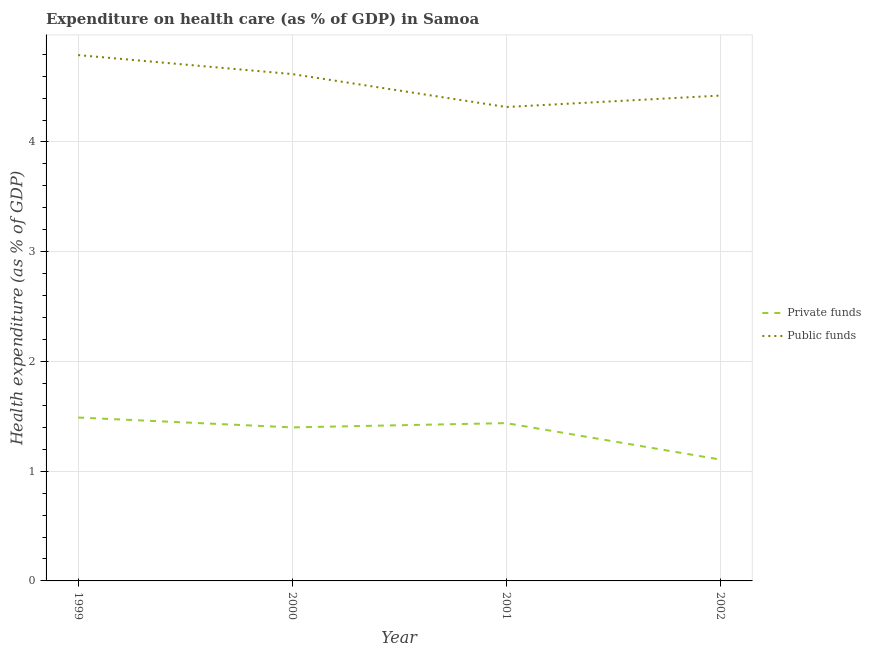How many different coloured lines are there?
Offer a very short reply. 2. Does the line corresponding to amount of public funds spent in healthcare intersect with the line corresponding to amount of private funds spent in healthcare?
Give a very brief answer. No. What is the amount of public funds spent in healthcare in 1999?
Offer a terse response. 4.79. Across all years, what is the maximum amount of public funds spent in healthcare?
Give a very brief answer. 4.79. Across all years, what is the minimum amount of private funds spent in healthcare?
Offer a very short reply. 1.11. In which year was the amount of private funds spent in healthcare maximum?
Keep it short and to the point. 1999. What is the total amount of public funds spent in healthcare in the graph?
Give a very brief answer. 18.15. What is the difference between the amount of public funds spent in healthcare in 1999 and that in 2001?
Your answer should be compact. 0.47. What is the difference between the amount of private funds spent in healthcare in 1999 and the amount of public funds spent in healthcare in 2000?
Give a very brief answer. -3.13. What is the average amount of public funds spent in healthcare per year?
Your answer should be compact. 4.54. In the year 2001, what is the difference between the amount of private funds spent in healthcare and amount of public funds spent in healthcare?
Provide a short and direct response. -2.88. In how many years, is the amount of private funds spent in healthcare greater than 1 %?
Your answer should be compact. 4. What is the ratio of the amount of public funds spent in healthcare in 2000 to that in 2002?
Keep it short and to the point. 1.04. Is the amount of public funds spent in healthcare in 2000 less than that in 2002?
Your answer should be very brief. No. Is the difference between the amount of private funds spent in healthcare in 2000 and 2002 greater than the difference between the amount of public funds spent in healthcare in 2000 and 2002?
Give a very brief answer. Yes. What is the difference between the highest and the second highest amount of private funds spent in healthcare?
Give a very brief answer. 0.05. What is the difference between the highest and the lowest amount of public funds spent in healthcare?
Your answer should be compact. 0.47. In how many years, is the amount of public funds spent in healthcare greater than the average amount of public funds spent in healthcare taken over all years?
Ensure brevity in your answer.  2. Is the amount of private funds spent in healthcare strictly greater than the amount of public funds spent in healthcare over the years?
Your answer should be very brief. No. Is the amount of private funds spent in healthcare strictly less than the amount of public funds spent in healthcare over the years?
Provide a short and direct response. Yes. How many lines are there?
Make the answer very short. 2. What is the difference between two consecutive major ticks on the Y-axis?
Your answer should be very brief. 1. Are the values on the major ticks of Y-axis written in scientific E-notation?
Your answer should be compact. No. Does the graph contain any zero values?
Make the answer very short. No. Where does the legend appear in the graph?
Your response must be concise. Center right. What is the title of the graph?
Your response must be concise. Expenditure on health care (as % of GDP) in Samoa. Does "Revenue" appear as one of the legend labels in the graph?
Ensure brevity in your answer.  No. What is the label or title of the X-axis?
Keep it short and to the point. Year. What is the label or title of the Y-axis?
Keep it short and to the point. Health expenditure (as % of GDP). What is the Health expenditure (as % of GDP) in Private funds in 1999?
Offer a terse response. 1.49. What is the Health expenditure (as % of GDP) in Public funds in 1999?
Offer a terse response. 4.79. What is the Health expenditure (as % of GDP) of Private funds in 2000?
Make the answer very short. 1.4. What is the Health expenditure (as % of GDP) of Public funds in 2000?
Provide a short and direct response. 4.62. What is the Health expenditure (as % of GDP) in Private funds in 2001?
Ensure brevity in your answer.  1.44. What is the Health expenditure (as % of GDP) in Public funds in 2001?
Provide a short and direct response. 4.32. What is the Health expenditure (as % of GDP) in Private funds in 2002?
Provide a succinct answer. 1.11. What is the Health expenditure (as % of GDP) in Public funds in 2002?
Offer a terse response. 4.42. Across all years, what is the maximum Health expenditure (as % of GDP) in Private funds?
Your answer should be compact. 1.49. Across all years, what is the maximum Health expenditure (as % of GDP) of Public funds?
Offer a terse response. 4.79. Across all years, what is the minimum Health expenditure (as % of GDP) of Private funds?
Your response must be concise. 1.11. Across all years, what is the minimum Health expenditure (as % of GDP) of Public funds?
Your answer should be compact. 4.32. What is the total Health expenditure (as % of GDP) in Private funds in the graph?
Make the answer very short. 5.43. What is the total Health expenditure (as % of GDP) of Public funds in the graph?
Provide a succinct answer. 18.15. What is the difference between the Health expenditure (as % of GDP) of Private funds in 1999 and that in 2000?
Your response must be concise. 0.09. What is the difference between the Health expenditure (as % of GDP) in Public funds in 1999 and that in 2000?
Your response must be concise. 0.17. What is the difference between the Health expenditure (as % of GDP) of Private funds in 1999 and that in 2001?
Your response must be concise. 0.05. What is the difference between the Health expenditure (as % of GDP) in Public funds in 1999 and that in 2001?
Keep it short and to the point. 0.47. What is the difference between the Health expenditure (as % of GDP) in Private funds in 1999 and that in 2002?
Offer a very short reply. 0.38. What is the difference between the Health expenditure (as % of GDP) in Public funds in 1999 and that in 2002?
Ensure brevity in your answer.  0.37. What is the difference between the Health expenditure (as % of GDP) in Private funds in 2000 and that in 2001?
Your response must be concise. -0.04. What is the difference between the Health expenditure (as % of GDP) in Public funds in 2000 and that in 2001?
Provide a short and direct response. 0.3. What is the difference between the Health expenditure (as % of GDP) in Private funds in 2000 and that in 2002?
Give a very brief answer. 0.29. What is the difference between the Health expenditure (as % of GDP) of Public funds in 2000 and that in 2002?
Offer a very short reply. 0.2. What is the difference between the Health expenditure (as % of GDP) in Private funds in 2001 and that in 2002?
Your answer should be compact. 0.33. What is the difference between the Health expenditure (as % of GDP) in Public funds in 2001 and that in 2002?
Offer a terse response. -0.1. What is the difference between the Health expenditure (as % of GDP) of Private funds in 1999 and the Health expenditure (as % of GDP) of Public funds in 2000?
Offer a terse response. -3.13. What is the difference between the Health expenditure (as % of GDP) in Private funds in 1999 and the Health expenditure (as % of GDP) in Public funds in 2001?
Ensure brevity in your answer.  -2.83. What is the difference between the Health expenditure (as % of GDP) in Private funds in 1999 and the Health expenditure (as % of GDP) in Public funds in 2002?
Offer a terse response. -2.93. What is the difference between the Health expenditure (as % of GDP) in Private funds in 2000 and the Health expenditure (as % of GDP) in Public funds in 2001?
Ensure brevity in your answer.  -2.92. What is the difference between the Health expenditure (as % of GDP) in Private funds in 2000 and the Health expenditure (as % of GDP) in Public funds in 2002?
Provide a succinct answer. -3.02. What is the difference between the Health expenditure (as % of GDP) of Private funds in 2001 and the Health expenditure (as % of GDP) of Public funds in 2002?
Ensure brevity in your answer.  -2.98. What is the average Health expenditure (as % of GDP) in Private funds per year?
Your response must be concise. 1.36. What is the average Health expenditure (as % of GDP) of Public funds per year?
Make the answer very short. 4.54. In the year 1999, what is the difference between the Health expenditure (as % of GDP) of Private funds and Health expenditure (as % of GDP) of Public funds?
Provide a short and direct response. -3.3. In the year 2000, what is the difference between the Health expenditure (as % of GDP) in Private funds and Health expenditure (as % of GDP) in Public funds?
Provide a succinct answer. -3.22. In the year 2001, what is the difference between the Health expenditure (as % of GDP) in Private funds and Health expenditure (as % of GDP) in Public funds?
Your answer should be very brief. -2.88. In the year 2002, what is the difference between the Health expenditure (as % of GDP) of Private funds and Health expenditure (as % of GDP) of Public funds?
Make the answer very short. -3.32. What is the ratio of the Health expenditure (as % of GDP) of Private funds in 1999 to that in 2000?
Your answer should be compact. 1.06. What is the ratio of the Health expenditure (as % of GDP) of Public funds in 1999 to that in 2000?
Your answer should be very brief. 1.04. What is the ratio of the Health expenditure (as % of GDP) of Private funds in 1999 to that in 2001?
Offer a very short reply. 1.04. What is the ratio of the Health expenditure (as % of GDP) of Public funds in 1999 to that in 2001?
Keep it short and to the point. 1.11. What is the ratio of the Health expenditure (as % of GDP) of Private funds in 1999 to that in 2002?
Your answer should be very brief. 1.35. What is the ratio of the Health expenditure (as % of GDP) in Public funds in 1999 to that in 2002?
Make the answer very short. 1.08. What is the ratio of the Health expenditure (as % of GDP) of Private funds in 2000 to that in 2001?
Give a very brief answer. 0.97. What is the ratio of the Health expenditure (as % of GDP) of Public funds in 2000 to that in 2001?
Make the answer very short. 1.07. What is the ratio of the Health expenditure (as % of GDP) of Private funds in 2000 to that in 2002?
Offer a terse response. 1.26. What is the ratio of the Health expenditure (as % of GDP) in Public funds in 2000 to that in 2002?
Offer a very short reply. 1.04. What is the ratio of the Health expenditure (as % of GDP) in Private funds in 2001 to that in 2002?
Keep it short and to the point. 1.3. What is the ratio of the Health expenditure (as % of GDP) of Public funds in 2001 to that in 2002?
Offer a very short reply. 0.98. What is the difference between the highest and the second highest Health expenditure (as % of GDP) of Private funds?
Ensure brevity in your answer.  0.05. What is the difference between the highest and the second highest Health expenditure (as % of GDP) of Public funds?
Make the answer very short. 0.17. What is the difference between the highest and the lowest Health expenditure (as % of GDP) of Private funds?
Make the answer very short. 0.38. What is the difference between the highest and the lowest Health expenditure (as % of GDP) in Public funds?
Ensure brevity in your answer.  0.47. 